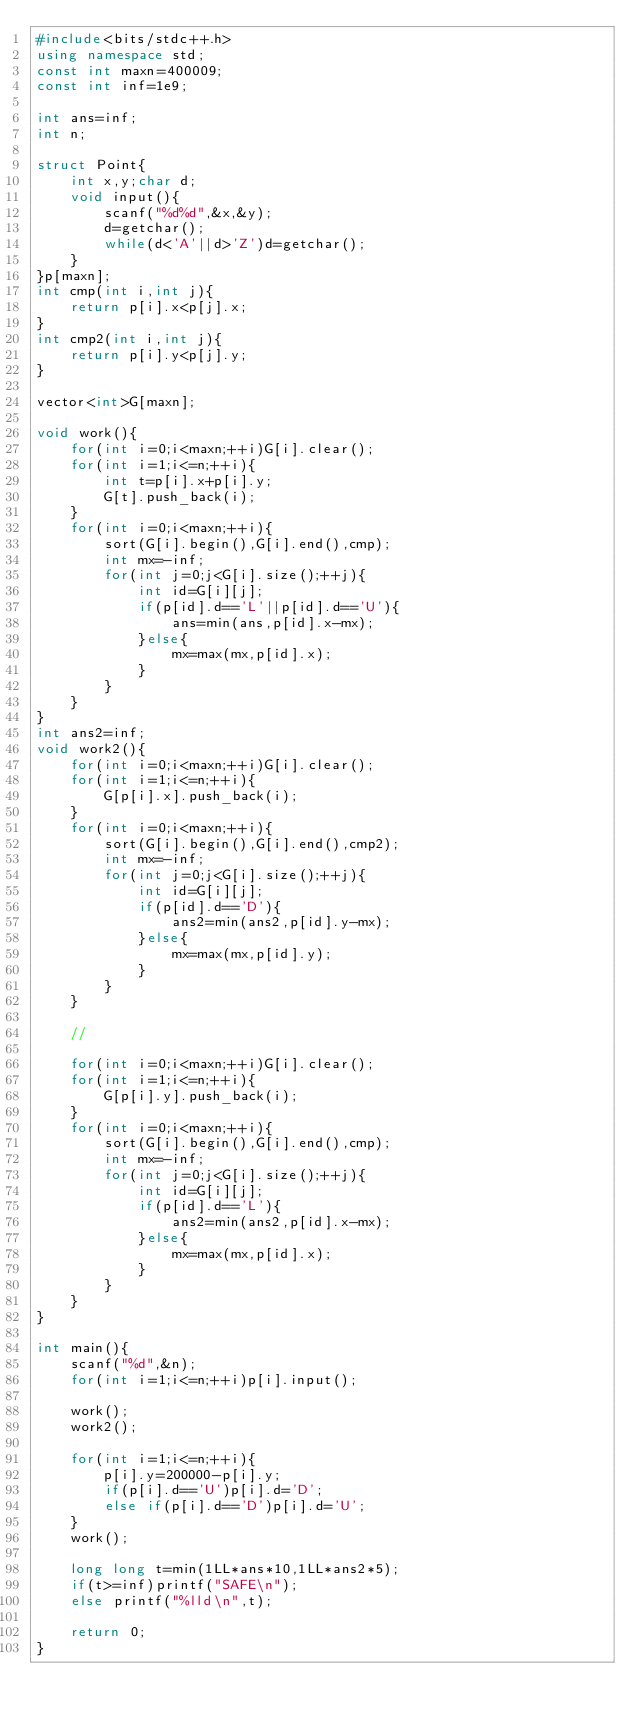Convert code to text. <code><loc_0><loc_0><loc_500><loc_500><_C++_>#include<bits/stdc++.h>
using namespace std;
const int maxn=400009;
const int inf=1e9;

int ans=inf;
int n;

struct Point{
	int x,y;char d;
	void input(){
		scanf("%d%d",&x,&y);
		d=getchar();
		while(d<'A'||d>'Z')d=getchar();
	}
}p[maxn];
int cmp(int i,int j){
	return p[i].x<p[j].x;
}
int cmp2(int i,int j){
	return p[i].y<p[j].y;
}

vector<int>G[maxn];

void work(){
	for(int i=0;i<maxn;++i)G[i].clear();
	for(int i=1;i<=n;++i){
		int t=p[i].x+p[i].y;
		G[t].push_back(i);
	}
	for(int i=0;i<maxn;++i){
		sort(G[i].begin(),G[i].end(),cmp);
		int mx=-inf;
		for(int j=0;j<G[i].size();++j){
			int id=G[i][j];
			if(p[id].d=='L'||p[id].d=='U'){
				ans=min(ans,p[id].x-mx);
			}else{
				mx=max(mx,p[id].x);
			}
		}
	}
}
int ans2=inf;
void work2(){
	for(int i=0;i<maxn;++i)G[i].clear();
	for(int i=1;i<=n;++i){
		G[p[i].x].push_back(i);
	}
	for(int i=0;i<maxn;++i){
		sort(G[i].begin(),G[i].end(),cmp2);
		int mx=-inf;
		for(int j=0;j<G[i].size();++j){
			int id=G[i][j];
			if(p[id].d=='D'){
				ans2=min(ans2,p[id].y-mx);
			}else{
				mx=max(mx,p[id].y);
			}
		}
	}
	
	//
	
	for(int i=0;i<maxn;++i)G[i].clear();
	for(int i=1;i<=n;++i){
		G[p[i].y].push_back(i);
	}
	for(int i=0;i<maxn;++i){
		sort(G[i].begin(),G[i].end(),cmp);
		int mx=-inf;
		for(int j=0;j<G[i].size();++j){
			int id=G[i][j];
			if(p[id].d=='L'){
				ans2=min(ans2,p[id].x-mx);
			}else{
				mx=max(mx,p[id].x);
			}
		}
	}
}

int main(){
	scanf("%d",&n);
	for(int i=1;i<=n;++i)p[i].input();
	
	work();
	work2();
	
	for(int i=1;i<=n;++i){
		p[i].y=200000-p[i].y;
		if(p[i].d=='U')p[i].d='D';
		else if(p[i].d=='D')p[i].d='U';
	}
	work();
	
	long long t=min(1LL*ans*10,1LL*ans2*5);
	if(t>=inf)printf("SAFE\n");
	else printf("%lld\n",t);
	
	return 0;
}</code> 